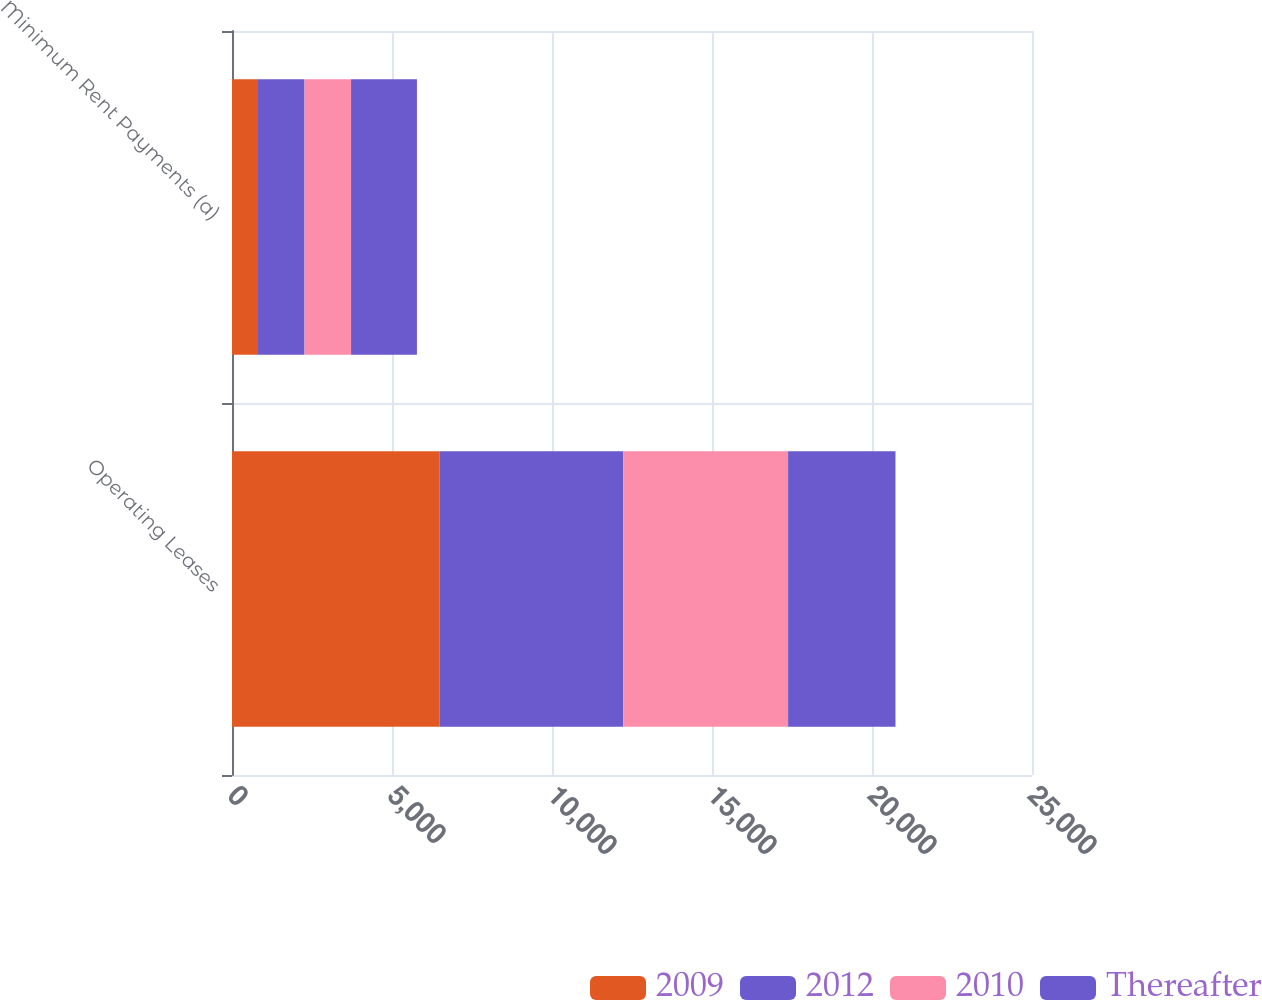Convert chart to OTSL. <chart><loc_0><loc_0><loc_500><loc_500><stacked_bar_chart><ecel><fcel>Operating Leases<fcel>Minimum Rent Payments (a)<nl><fcel>2009<fcel>6491<fcel>813<nl><fcel>2012<fcel>5733<fcel>1454<nl><fcel>2010<fcel>5154<fcel>1454<nl><fcel>Thereafter<fcel>3356<fcel>2058<nl></chart> 